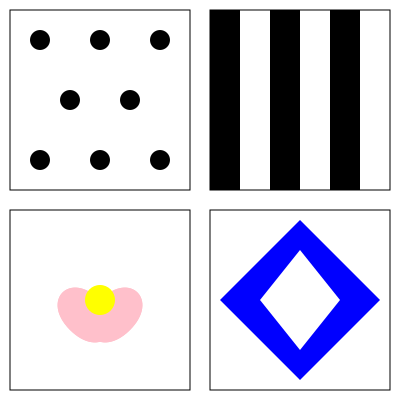Analyze the four textile patterns shown in the image above. Which pattern would be most effective in evoking a sense of stability and confidence for a romantic comedy protagonist facing a challenging career decision, and why? To answer this question, we need to consider the psychological impact of each pattern and how it relates to stability and confidence in a career context:

1. Polka Dots (Top Left):
   - Associated with playfulness and whimsy
   - Can evoke a sense of fun and lightheartedness
   - May not convey the seriousness required for a career decision

2. Stripes (Top Right):
   - Represent order, structure, and predictability
   - Vertical stripes can suggest strength and stability
   - Associated with professionalism and confidence

3. Floral (Bottom Left):
   - Symbolizes growth, femininity, and natural beauty
   - Can evoke feelings of comfort and optimism
   - May be seen as too soft or casual for a career-focused scenario

4. Geometric (Bottom Right):
   - Represents balance, symmetry, and modernity
   - Can evoke a sense of order and clarity
   - May be perceived as too abstract or impersonal

Considering the context of a romantic comedy protagonist facing a challenging career decision, the pattern that would be most effective in evoking a sense of stability and confidence is the striped pattern.

Reasons:
1. Professionalism: Stripes are often associated with business attire, making them suitable for a career-focused scenario.
2. Structure: The regular, predictable nature of stripes can provide a sense of order and control, which is beneficial when facing a challenging decision.
3. Confidence: Vertical stripes, in particular, can make the wearer appear taller and more self-assured.
4. Stability: The consistent, unchanging nature of stripes represents stability in an uncertain situation.
5. Balance: While conveying professionalism, stripes are not overly serious, maintaining the light-hearted essence of a romantic comedy.

The striped pattern strikes the right balance between professionalism and approachability, making it the most effective choice for a romantic comedy protagonist navigating a career decision while maintaining their endearing character.
Answer: Striped pattern 